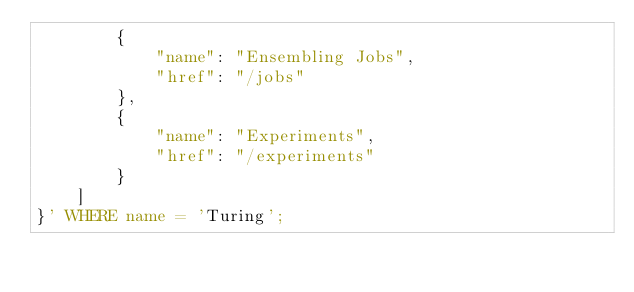<code> <loc_0><loc_0><loc_500><loc_500><_SQL_>        {
            "name": "Ensembling Jobs",
            "href": "/jobs"
        },
        {
            "name": "Experiments",
            "href": "/experiments"
        }
    ]
}' WHERE name = 'Turing';</code> 